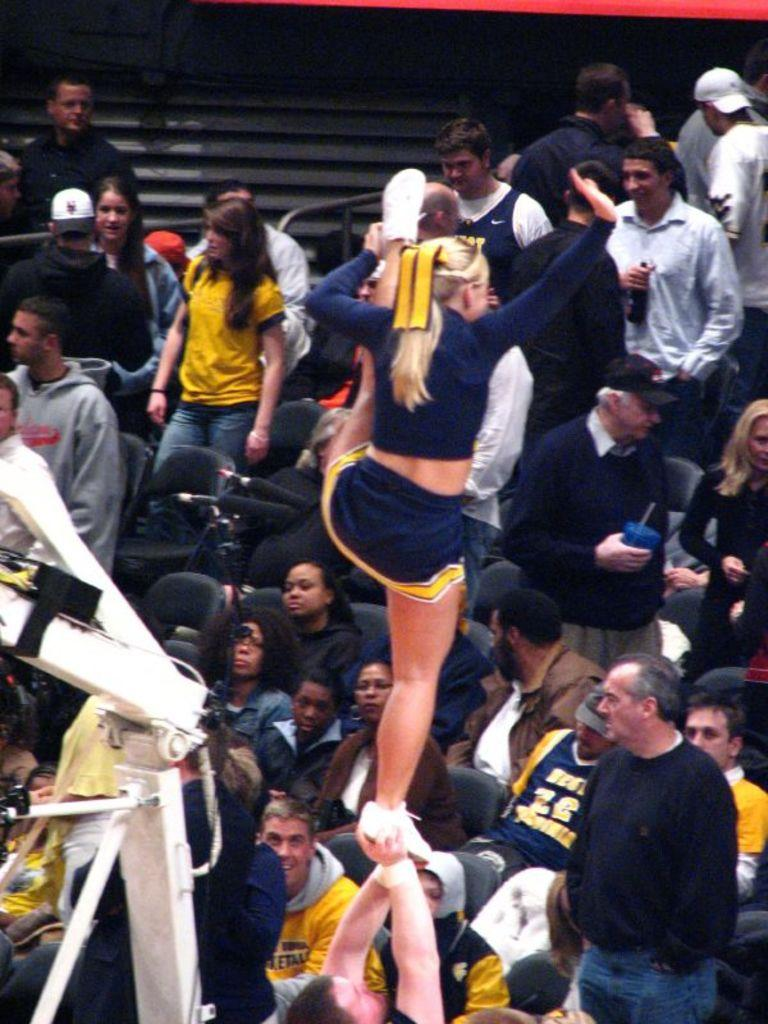What is the woman in the image doing? The woman is standing on the hands of another person in the image. How many people are in the image? There is a group of people in the image. What type of furniture is present in the image? Chairs are present in the image. Can you describe any other objects visible in the image? There are other objects visible in the image, but their specific details are not mentioned in the provided facts. What type of ink is being used by the woman in the image? There is no ink present in the image; the woman is standing on the hands of another person. What type of business is being conducted in the image? There is no indication of any business activity in the image; it primarily features a woman standing on the hands of another person and a group of people. 